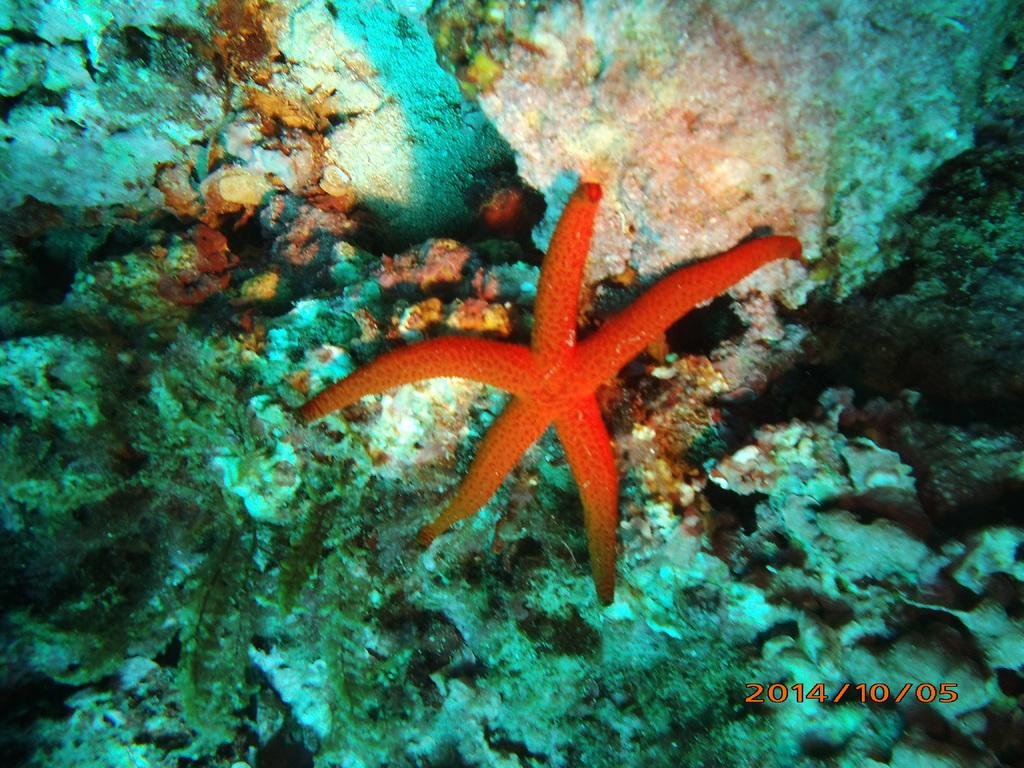What type of animal is in the image? There is a starfish in the image. Can you describe the setting of the image? The image depicts an underwater environment. How many tomatoes can be seen growing on the mountain in the image? There are no tomatoes or mountains present in the image; it depicts an underwater environment with a starfish. 